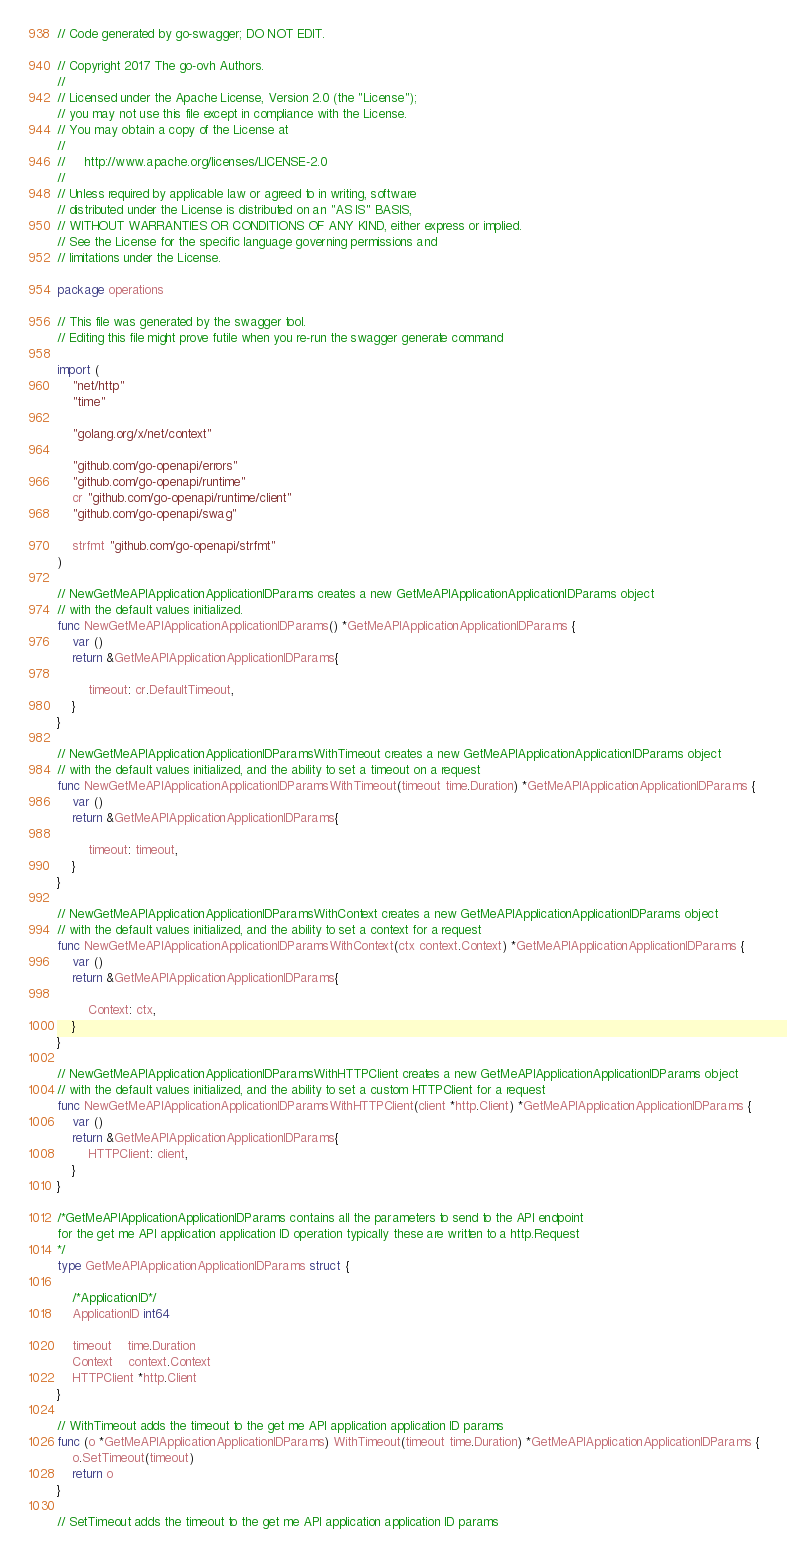Convert code to text. <code><loc_0><loc_0><loc_500><loc_500><_Go_>// Code generated by go-swagger; DO NOT EDIT.

// Copyright 2017 The go-ovh Authors.
//
// Licensed under the Apache License, Version 2.0 (the "License");
// you may not use this file except in compliance with the License.
// You may obtain a copy of the License at
//
//     http://www.apache.org/licenses/LICENSE-2.0
//
// Unless required by applicable law or agreed to in writing, software
// distributed under the License is distributed on an "AS IS" BASIS,
// WITHOUT WARRANTIES OR CONDITIONS OF ANY KIND, either express or implied.
// See the License for the specific language governing permissions and
// limitations under the License.

package operations

// This file was generated by the swagger tool.
// Editing this file might prove futile when you re-run the swagger generate command

import (
	"net/http"
	"time"

	"golang.org/x/net/context"

	"github.com/go-openapi/errors"
	"github.com/go-openapi/runtime"
	cr "github.com/go-openapi/runtime/client"
	"github.com/go-openapi/swag"

	strfmt "github.com/go-openapi/strfmt"
)

// NewGetMeAPIApplicationApplicationIDParams creates a new GetMeAPIApplicationApplicationIDParams object
// with the default values initialized.
func NewGetMeAPIApplicationApplicationIDParams() *GetMeAPIApplicationApplicationIDParams {
	var ()
	return &GetMeAPIApplicationApplicationIDParams{

		timeout: cr.DefaultTimeout,
	}
}

// NewGetMeAPIApplicationApplicationIDParamsWithTimeout creates a new GetMeAPIApplicationApplicationIDParams object
// with the default values initialized, and the ability to set a timeout on a request
func NewGetMeAPIApplicationApplicationIDParamsWithTimeout(timeout time.Duration) *GetMeAPIApplicationApplicationIDParams {
	var ()
	return &GetMeAPIApplicationApplicationIDParams{

		timeout: timeout,
	}
}

// NewGetMeAPIApplicationApplicationIDParamsWithContext creates a new GetMeAPIApplicationApplicationIDParams object
// with the default values initialized, and the ability to set a context for a request
func NewGetMeAPIApplicationApplicationIDParamsWithContext(ctx context.Context) *GetMeAPIApplicationApplicationIDParams {
	var ()
	return &GetMeAPIApplicationApplicationIDParams{

		Context: ctx,
	}
}

// NewGetMeAPIApplicationApplicationIDParamsWithHTTPClient creates a new GetMeAPIApplicationApplicationIDParams object
// with the default values initialized, and the ability to set a custom HTTPClient for a request
func NewGetMeAPIApplicationApplicationIDParamsWithHTTPClient(client *http.Client) *GetMeAPIApplicationApplicationIDParams {
	var ()
	return &GetMeAPIApplicationApplicationIDParams{
		HTTPClient: client,
	}
}

/*GetMeAPIApplicationApplicationIDParams contains all the parameters to send to the API endpoint
for the get me API application application ID operation typically these are written to a http.Request
*/
type GetMeAPIApplicationApplicationIDParams struct {

	/*ApplicationID*/
	ApplicationID int64

	timeout    time.Duration
	Context    context.Context
	HTTPClient *http.Client
}

// WithTimeout adds the timeout to the get me API application application ID params
func (o *GetMeAPIApplicationApplicationIDParams) WithTimeout(timeout time.Duration) *GetMeAPIApplicationApplicationIDParams {
	o.SetTimeout(timeout)
	return o
}

// SetTimeout adds the timeout to the get me API application application ID params</code> 